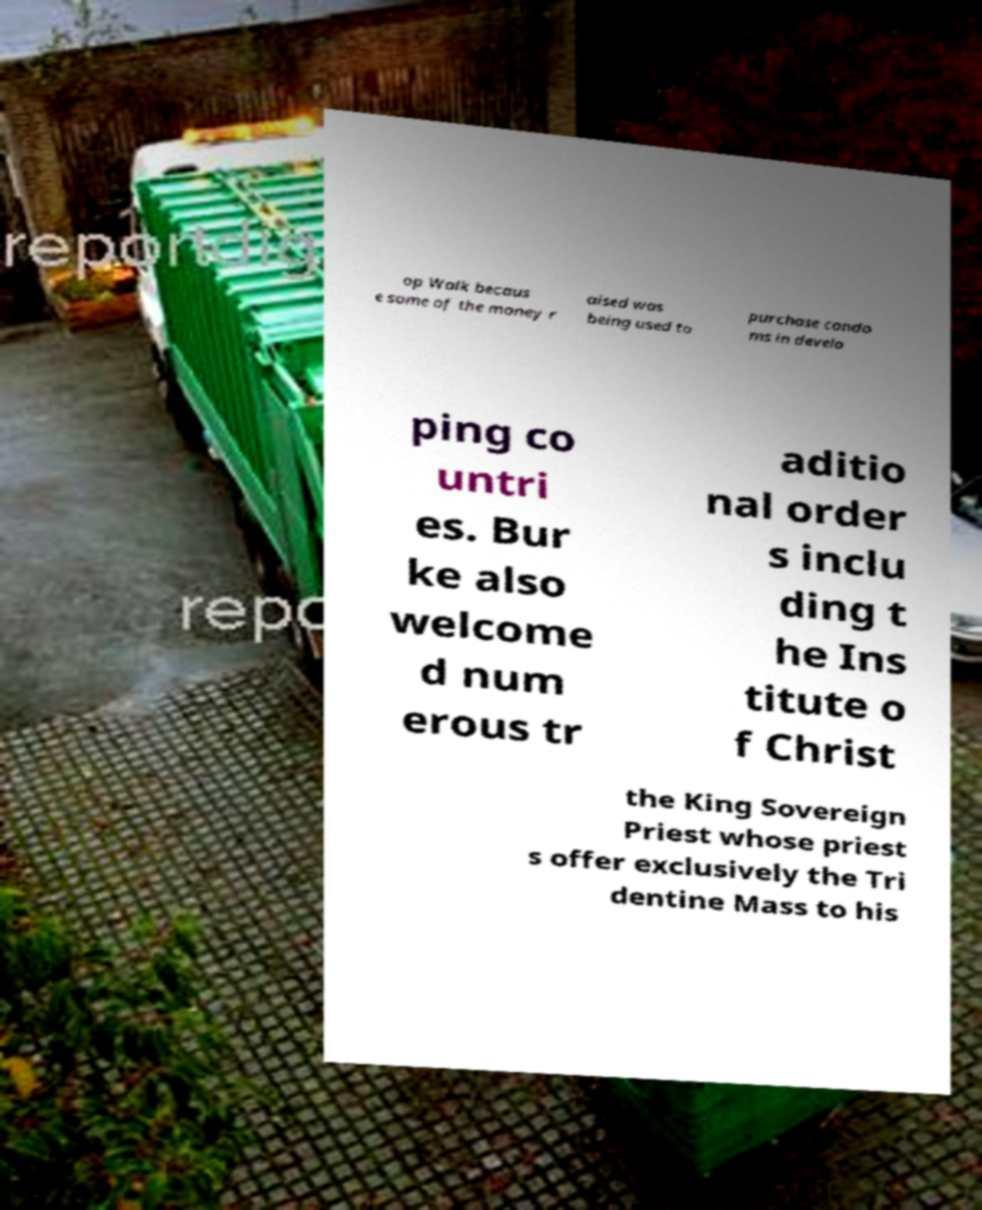What messages or text are displayed in this image? I need them in a readable, typed format. op Walk becaus e some of the money r aised was being used to purchase condo ms in develo ping co untri es. Bur ke also welcome d num erous tr aditio nal order s inclu ding t he Ins titute o f Christ the King Sovereign Priest whose priest s offer exclusively the Tri dentine Mass to his 